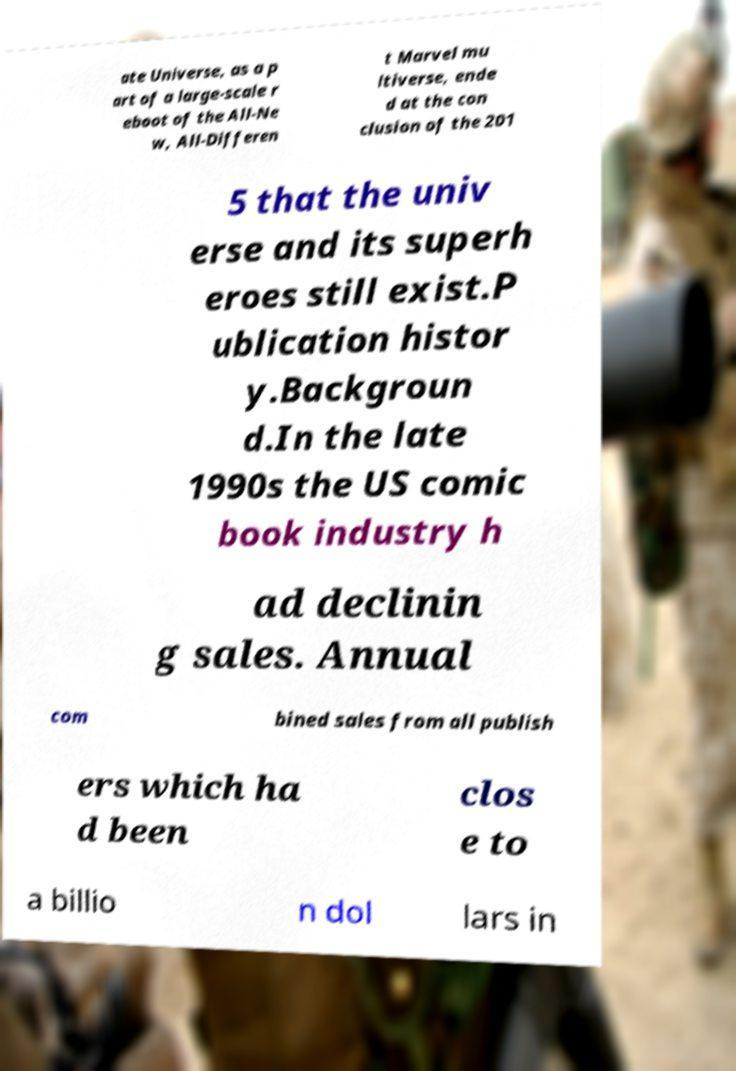Please read and relay the text visible in this image. What does it say? ate Universe, as a p art of a large-scale r eboot of the All-Ne w, All-Differen t Marvel mu ltiverse, ende d at the con clusion of the 201 5 that the univ erse and its superh eroes still exist.P ublication histor y.Backgroun d.In the late 1990s the US comic book industry h ad declinin g sales. Annual com bined sales from all publish ers which ha d been clos e to a billio n dol lars in 